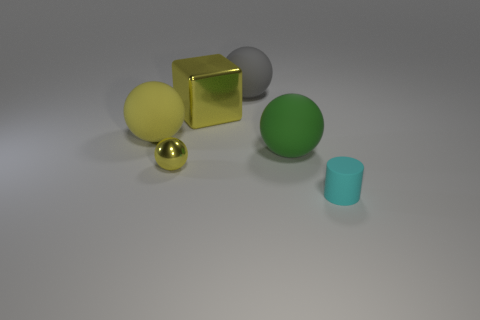Is the number of large green rubber balls to the left of the green sphere greater than the number of red rubber spheres?
Provide a succinct answer. No. What material is the big yellow cube?
Provide a succinct answer. Metal. What shape is the tiny object that is made of the same material as the big green object?
Provide a succinct answer. Cylinder. What is the size of the matte thing that is behind the shiny thing that is behind the green ball?
Your answer should be compact. Large. There is a large sphere that is to the left of the big gray matte sphere; what color is it?
Offer a very short reply. Yellow. Are there any brown things that have the same shape as the cyan object?
Make the answer very short. No. Are there fewer balls behind the yellow metal ball than tiny cyan matte cylinders to the right of the cylinder?
Provide a succinct answer. No. What color is the small shiny sphere?
Your answer should be compact. Yellow. There is a yellow shiny object that is behind the yellow matte ball; is there a cyan thing behind it?
Make the answer very short. No. What number of green matte balls have the same size as the block?
Provide a succinct answer. 1. 